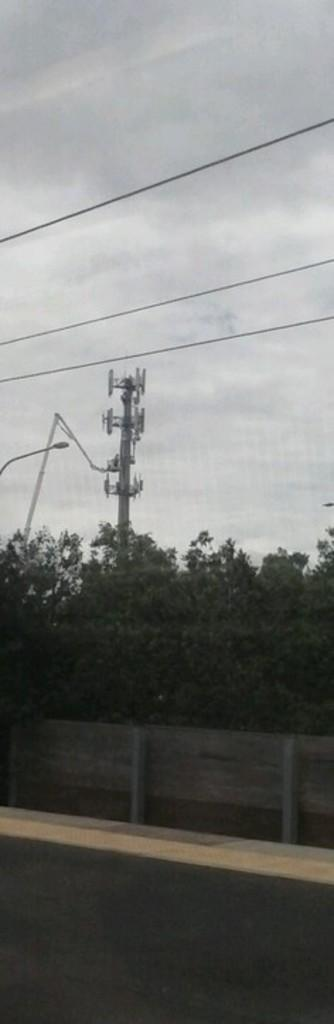What type of pathway is visible in the image? There is a road in the image. What is used to enclose or separate areas in the image? There is fencing in the image. What type of vegetation can be seen in the image? There are trees in the image. What type of electrical equipment is present in the image? There is a transformer in the image. What is used to transmit electricity in the image? There are wires in the image. Can you tell me how many times the transformer can fit into the pocket in the image? There is no pocket present in the image, and therefore the transformer cannot be placed into a pocket. What type of coil is used to create the wires in the image? The image does not show the specific type of coil used to create the wires; it only shows the wires themselves. 